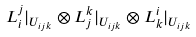Convert formula to latex. <formula><loc_0><loc_0><loc_500><loc_500>L ^ { j } _ { i } | _ { U _ { i j k } } \otimes L ^ { k } _ { j } | _ { U _ { i j k } } \otimes L ^ { i } _ { k } | _ { U _ { i j k } }</formula> 